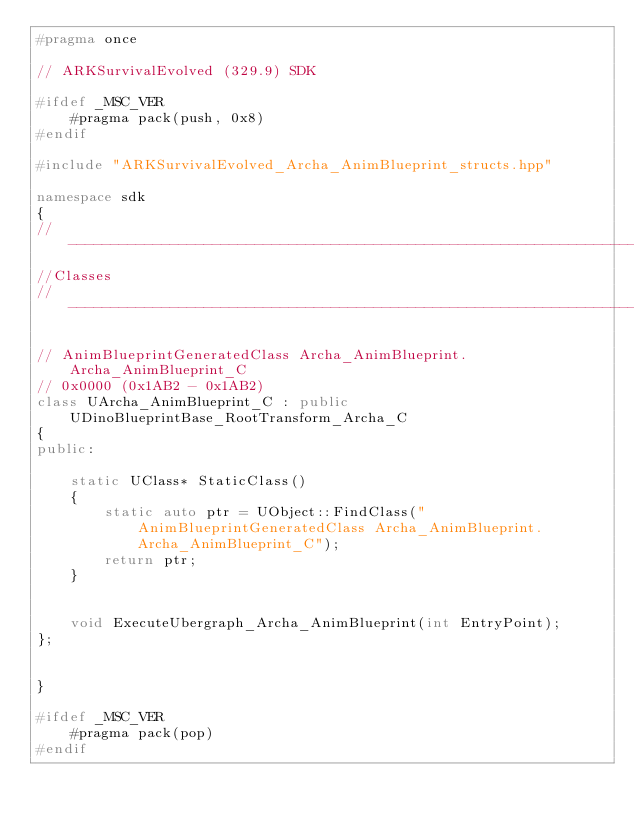Convert code to text. <code><loc_0><loc_0><loc_500><loc_500><_C++_>#pragma once

// ARKSurvivalEvolved (329.9) SDK

#ifdef _MSC_VER
	#pragma pack(push, 0x8)
#endif

#include "ARKSurvivalEvolved_Archa_AnimBlueprint_structs.hpp"

namespace sdk
{
//---------------------------------------------------------------------------
//Classes
//---------------------------------------------------------------------------

// AnimBlueprintGeneratedClass Archa_AnimBlueprint.Archa_AnimBlueprint_C
// 0x0000 (0x1AB2 - 0x1AB2)
class UArcha_AnimBlueprint_C : public UDinoBlueprintBase_RootTransform_Archa_C
{
public:

	static UClass* StaticClass()
	{
		static auto ptr = UObject::FindClass("AnimBlueprintGeneratedClass Archa_AnimBlueprint.Archa_AnimBlueprint_C");
		return ptr;
	}


	void ExecuteUbergraph_Archa_AnimBlueprint(int EntryPoint);
};


}

#ifdef _MSC_VER
	#pragma pack(pop)
#endif
</code> 